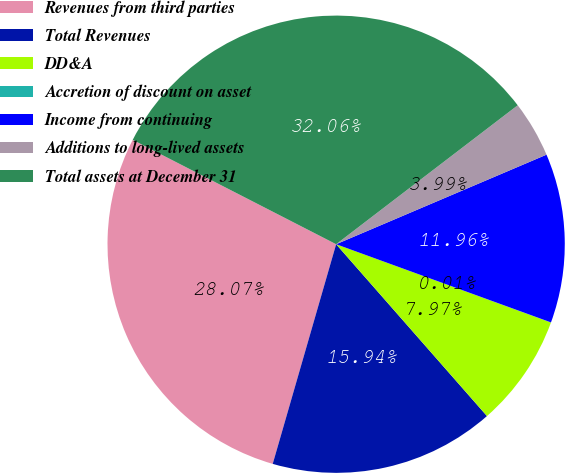Convert chart. <chart><loc_0><loc_0><loc_500><loc_500><pie_chart><fcel>Revenues from third parties<fcel>Total Revenues<fcel>DD&A<fcel>Accretion of discount on asset<fcel>Income from continuing<fcel>Additions to long-lived assets<fcel>Total assets at December 31<nl><fcel>28.07%<fcel>15.94%<fcel>7.97%<fcel>0.01%<fcel>11.96%<fcel>3.99%<fcel>32.06%<nl></chart> 